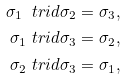<formula> <loc_0><loc_0><loc_500><loc_500>\sigma _ { 1 } \ t r i d \sigma _ { 2 } & = \sigma _ { 3 } , \\ \sigma _ { 1 } \ t r i d \sigma _ { 3 } & = \sigma _ { 2 } , \\ \sigma _ { 2 } \ t r i d \sigma _ { 3 } & = \sigma _ { 1 } ,</formula> 